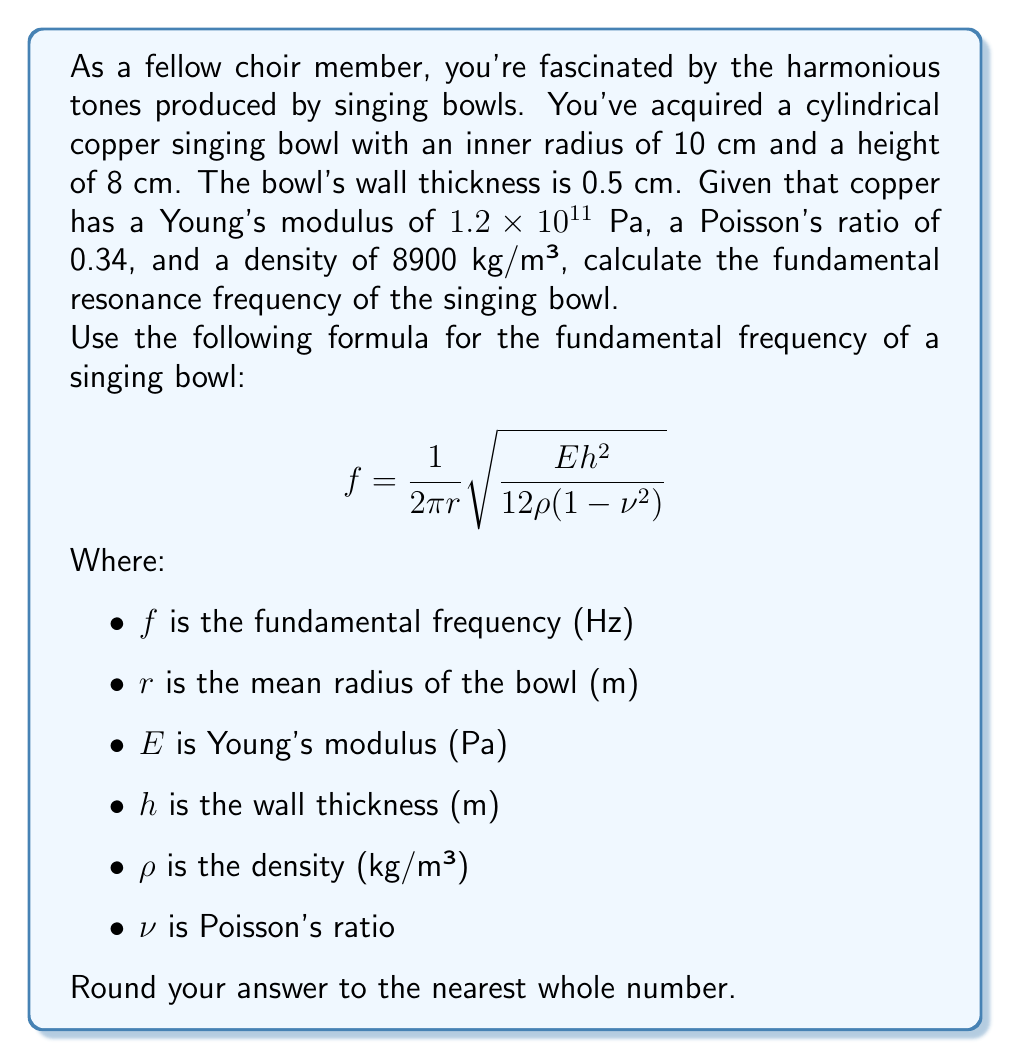Can you answer this question? To solve this problem, we'll follow these steps:

1) First, let's identify the given values:
   $r_{inner} = 10$ cm = 0.10 m
   $h$ (wall thickness) = 0.5 cm = 0.005 m
   $E$ (Young's modulus) = $1.2 \times 10^{11}$ Pa
   $\rho$ (density) = 8900 kg/m³
   $\nu$ (Poisson's ratio) = 0.34

2) We need to calculate the mean radius $r$:
   $r = r_{inner} + \frac{h}{2} = 0.10 + \frac{0.005}{2} = 0.1025$ m

3) Now we can substitute these values into the given formula:

   $$f = \frac{1}{2\pi (0.1025)} \sqrt{\frac{(1.2 \times 10^{11}) (0.005)^2}{12 (8900) (1-0.34^2)}}$$

4) Let's simplify the expression under the square root first:

   $$\frac{(1.2 \times 10^{11}) (0.005)^2}{12 (8900) (1-0.34^2)} = \frac{(1.2 \times 10^{11}) (2.5 \times 10^{-5})}{12 (8900) (0.8844)} = 2951.97$$

5) Now we can complete the calculation:

   $$f = \frac{1}{2\pi (0.1025)} \sqrt{2951.97} = \frac{54.33}{0.6439} = 84.38 \text{ Hz}$$

6) Rounding to the nearest whole number:

   $f \approx 84$ Hz
Answer: 84 Hz 